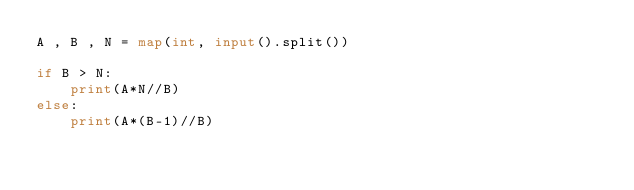<code> <loc_0><loc_0><loc_500><loc_500><_Python_>A , B , N = map(int, input().split())

if B > N:
    print(A*N//B)
else:
    print(A*(B-1)//B)</code> 